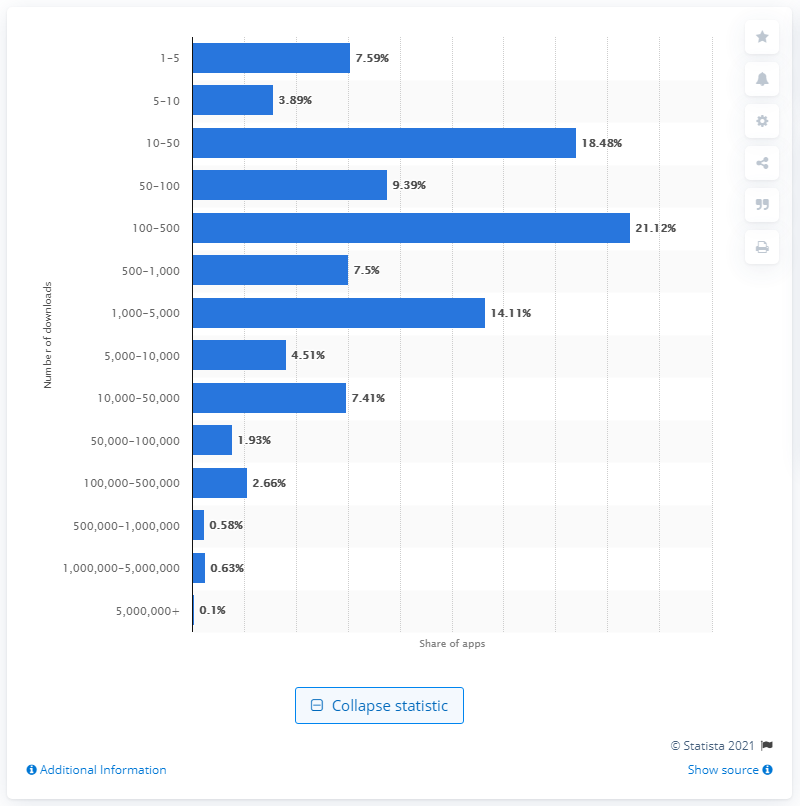Identify some key points in this picture. According to data, only 0.1% of apps have successfully accumulated more than five million downloads. 